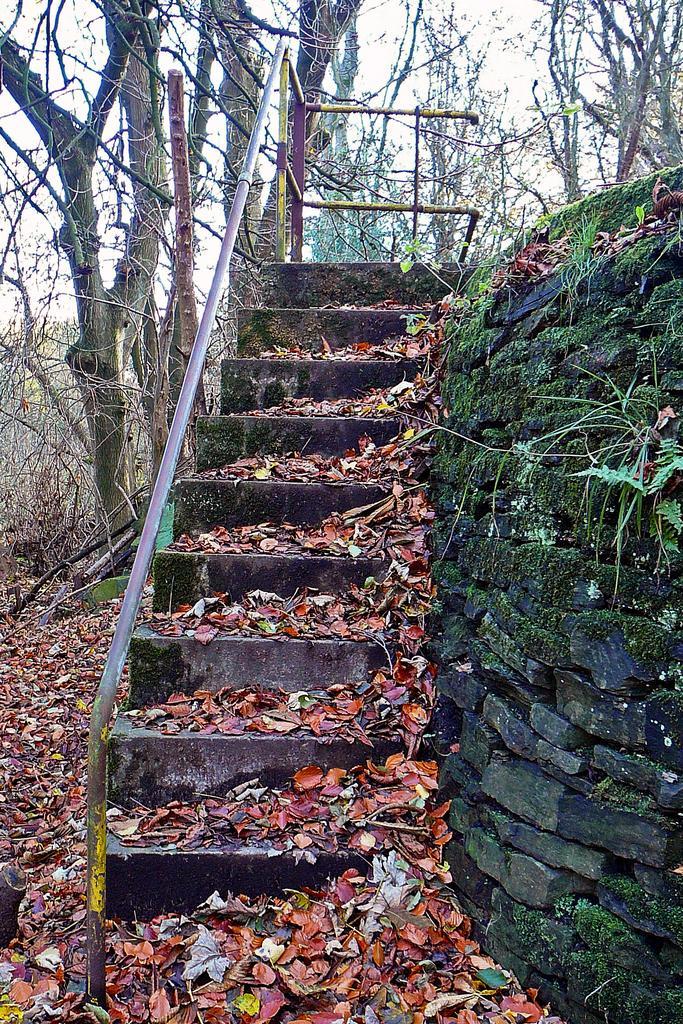Can you describe this image briefly? In the image I can see a staircase on which there are some dry leaves and also I can see some trees and a rock wall. 